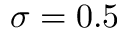<formula> <loc_0><loc_0><loc_500><loc_500>\sigma = 0 . 5</formula> 